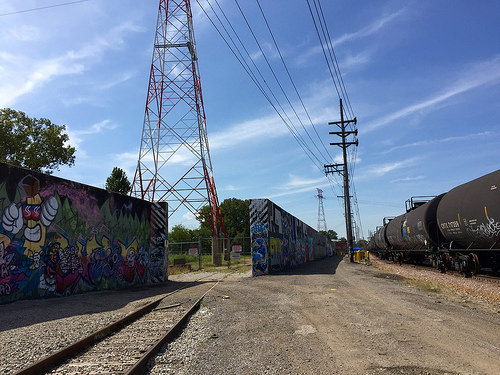<image>
Can you confirm if the tower is in front of the sky? Yes. The tower is positioned in front of the sky, appearing closer to the camera viewpoint. 